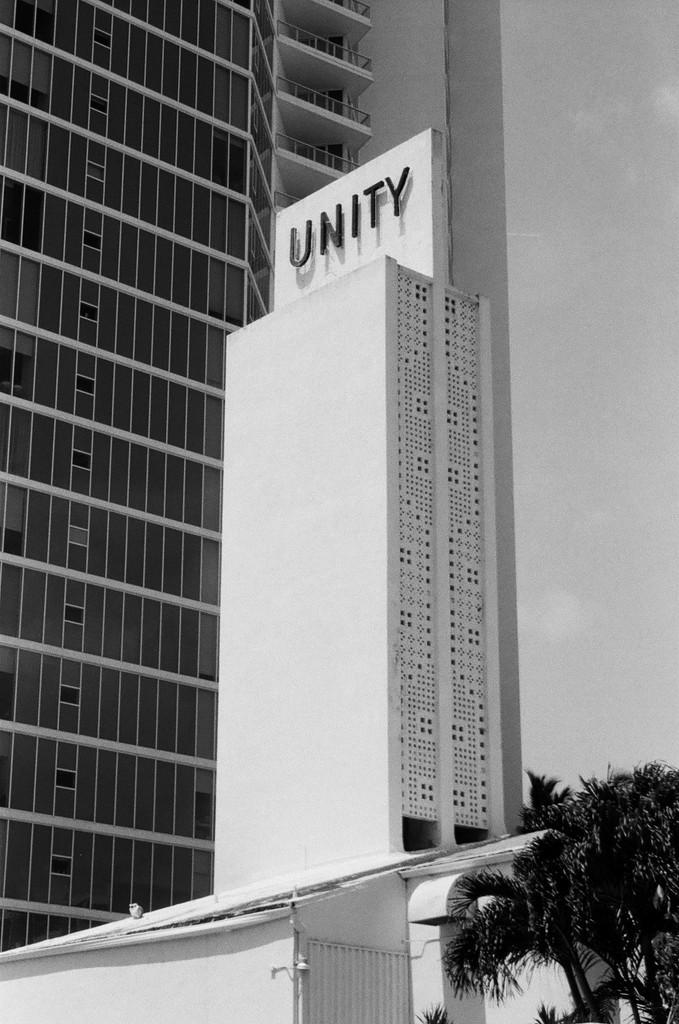What type of structures are present in the image? There are tall buildings in the image. What type of vegetation can be seen at the bottom of the image? There are trees visible at the bottom of the image. What type of comb is being used to style the bun in the image? There is no comb or bun present in the image; it features tall buildings and trees. 